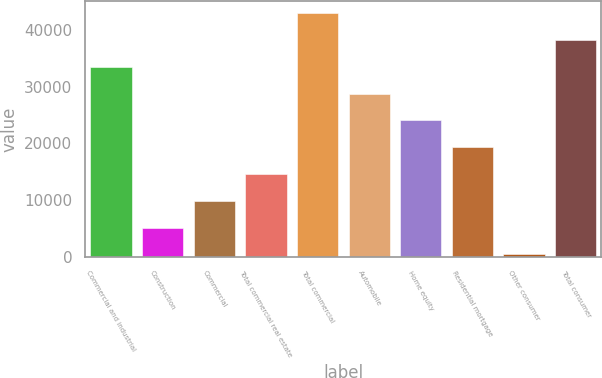Convert chart to OTSL. <chart><loc_0><loc_0><loc_500><loc_500><bar_chart><fcel>Commercial and industrial<fcel>Construction<fcel>Commercial<fcel>Total commercial real estate<fcel>Total commercial<fcel>Automobile<fcel>Home equity<fcel>Residential mortgage<fcel>Other consumer<fcel>Total consumer<nl><fcel>33483.4<fcel>5138.2<fcel>9862.4<fcel>14586.6<fcel>42931.8<fcel>28759.2<fcel>24035<fcel>19310.8<fcel>414<fcel>38207.6<nl></chart> 